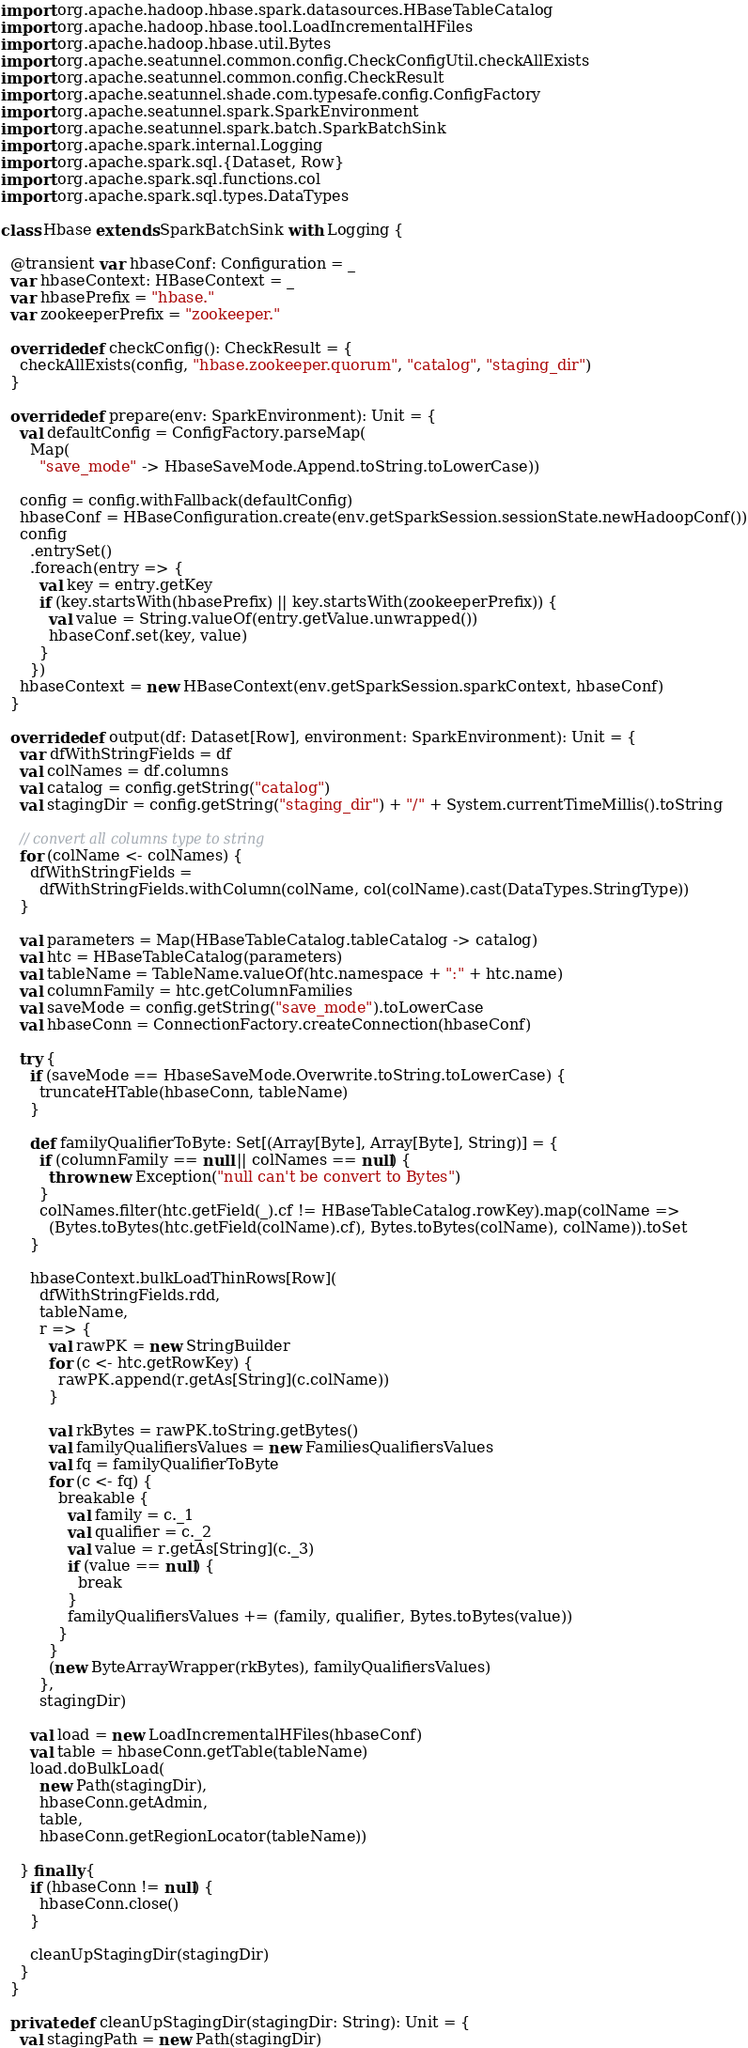Convert code to text. <code><loc_0><loc_0><loc_500><loc_500><_Scala_>import org.apache.hadoop.hbase.spark.datasources.HBaseTableCatalog
import org.apache.hadoop.hbase.tool.LoadIncrementalHFiles
import org.apache.hadoop.hbase.util.Bytes
import org.apache.seatunnel.common.config.CheckConfigUtil.checkAllExists
import org.apache.seatunnel.common.config.CheckResult
import org.apache.seatunnel.shade.com.typesafe.config.ConfigFactory
import org.apache.seatunnel.spark.SparkEnvironment
import org.apache.seatunnel.spark.batch.SparkBatchSink
import org.apache.spark.internal.Logging
import org.apache.spark.sql.{Dataset, Row}
import org.apache.spark.sql.functions.col
import org.apache.spark.sql.types.DataTypes

class Hbase extends SparkBatchSink with Logging {

  @transient var hbaseConf: Configuration = _
  var hbaseContext: HBaseContext = _
  var hbasePrefix = "hbase."
  var zookeeperPrefix = "zookeeper."

  override def checkConfig(): CheckResult = {
    checkAllExists(config, "hbase.zookeeper.quorum", "catalog", "staging_dir")
  }

  override def prepare(env: SparkEnvironment): Unit = {
    val defaultConfig = ConfigFactory.parseMap(
      Map(
        "save_mode" -> HbaseSaveMode.Append.toString.toLowerCase))

    config = config.withFallback(defaultConfig)
    hbaseConf = HBaseConfiguration.create(env.getSparkSession.sessionState.newHadoopConf())
    config
      .entrySet()
      .foreach(entry => {
        val key = entry.getKey
        if (key.startsWith(hbasePrefix) || key.startsWith(zookeeperPrefix)) {
          val value = String.valueOf(entry.getValue.unwrapped())
          hbaseConf.set(key, value)
        }
      })
    hbaseContext = new HBaseContext(env.getSparkSession.sparkContext, hbaseConf)
  }

  override def output(df: Dataset[Row], environment: SparkEnvironment): Unit = {
    var dfWithStringFields = df
    val colNames = df.columns
    val catalog = config.getString("catalog")
    val stagingDir = config.getString("staging_dir") + "/" + System.currentTimeMillis().toString

    // convert all columns type to string
    for (colName <- colNames) {
      dfWithStringFields =
        dfWithStringFields.withColumn(colName, col(colName).cast(DataTypes.StringType))
    }

    val parameters = Map(HBaseTableCatalog.tableCatalog -> catalog)
    val htc = HBaseTableCatalog(parameters)
    val tableName = TableName.valueOf(htc.namespace + ":" + htc.name)
    val columnFamily = htc.getColumnFamilies
    val saveMode = config.getString("save_mode").toLowerCase
    val hbaseConn = ConnectionFactory.createConnection(hbaseConf)

    try {
      if (saveMode == HbaseSaveMode.Overwrite.toString.toLowerCase) {
        truncateHTable(hbaseConn, tableName)
      }

      def familyQualifierToByte: Set[(Array[Byte], Array[Byte], String)] = {
        if (columnFamily == null || colNames == null) {
          throw new Exception("null can't be convert to Bytes")
        }
        colNames.filter(htc.getField(_).cf != HBaseTableCatalog.rowKey).map(colName =>
          (Bytes.toBytes(htc.getField(colName).cf), Bytes.toBytes(colName), colName)).toSet
      }

      hbaseContext.bulkLoadThinRows[Row](
        dfWithStringFields.rdd,
        tableName,
        r => {
          val rawPK = new StringBuilder
          for (c <- htc.getRowKey) {
            rawPK.append(r.getAs[String](c.colName))
          }

          val rkBytes = rawPK.toString.getBytes()
          val familyQualifiersValues = new FamiliesQualifiersValues
          val fq = familyQualifierToByte
          for (c <- fq) {
            breakable {
              val family = c._1
              val qualifier = c._2
              val value = r.getAs[String](c._3)
              if (value == null) {
                break
              }
              familyQualifiersValues += (family, qualifier, Bytes.toBytes(value))
            }
          }
          (new ByteArrayWrapper(rkBytes), familyQualifiersValues)
        },
        stagingDir)

      val load = new LoadIncrementalHFiles(hbaseConf)
      val table = hbaseConn.getTable(tableName)
      load.doBulkLoad(
        new Path(stagingDir),
        hbaseConn.getAdmin,
        table,
        hbaseConn.getRegionLocator(tableName))

    } finally {
      if (hbaseConn != null) {
        hbaseConn.close()
      }

      cleanUpStagingDir(stagingDir)
    }
  }

  private def cleanUpStagingDir(stagingDir: String): Unit = {
    val stagingPath = new Path(stagingDir)</code> 